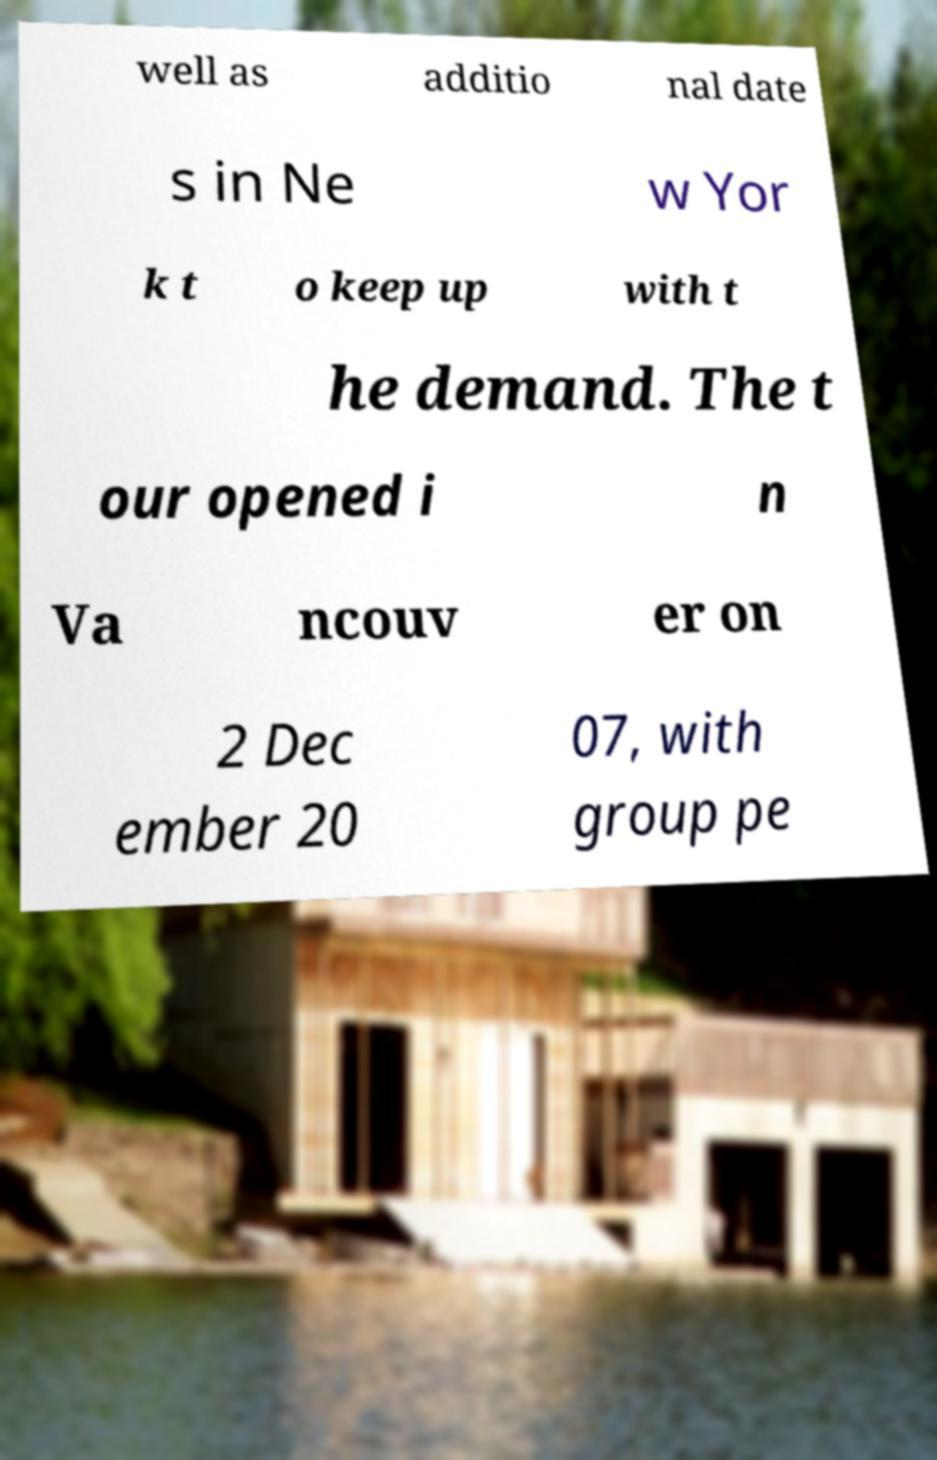For documentation purposes, I need the text within this image transcribed. Could you provide that? well as additio nal date s in Ne w Yor k t o keep up with t he demand. The t our opened i n Va ncouv er on 2 Dec ember 20 07, with group pe 